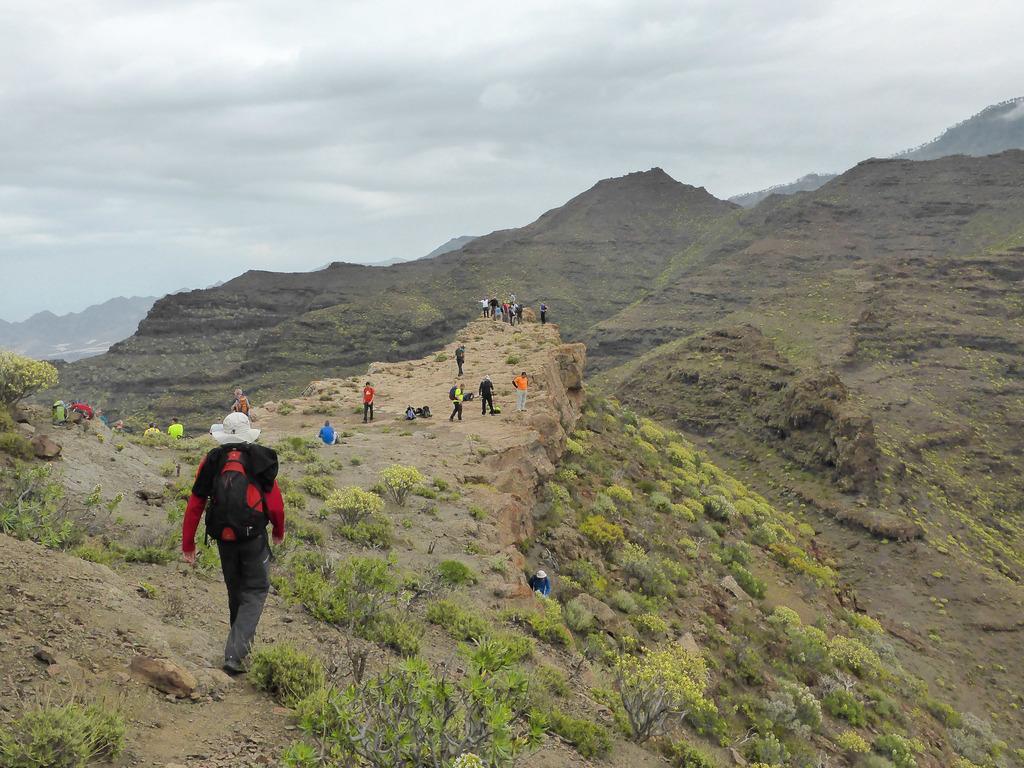Please provide a concise description of this image. In this picture I can see there is a man walking here and wearing a red coat and a red bag, there are some other people standing on the cliff in the backdrop. There are plants on the mountain and there are some mountains in the backdrop and the sky is cloudy. 